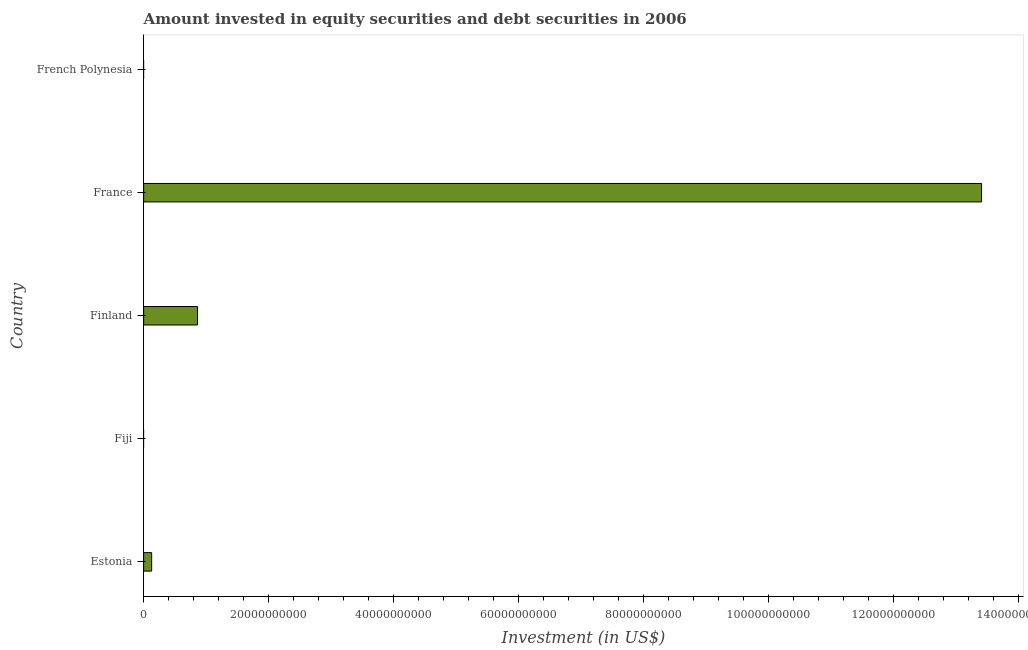Does the graph contain grids?
Your response must be concise. No. What is the title of the graph?
Your response must be concise. Amount invested in equity securities and debt securities in 2006. What is the label or title of the X-axis?
Keep it short and to the point. Investment (in US$). What is the label or title of the Y-axis?
Make the answer very short. Country. What is the portfolio investment in Finland?
Provide a succinct answer. 8.63e+09. Across all countries, what is the maximum portfolio investment?
Your answer should be compact. 1.34e+11. In which country was the portfolio investment maximum?
Your answer should be very brief. France. What is the sum of the portfolio investment?
Provide a short and direct response. 1.44e+11. What is the difference between the portfolio investment in Estonia and Finland?
Your answer should be very brief. -7.35e+09. What is the average portfolio investment per country?
Offer a terse response. 2.88e+1. What is the median portfolio investment?
Provide a succinct answer. 1.28e+09. Is the difference between the portfolio investment in Finland and France greater than the difference between any two countries?
Your response must be concise. No. What is the difference between the highest and the second highest portfolio investment?
Keep it short and to the point. 1.26e+11. Is the sum of the portfolio investment in Estonia and France greater than the maximum portfolio investment across all countries?
Provide a short and direct response. Yes. What is the difference between the highest and the lowest portfolio investment?
Provide a succinct answer. 1.34e+11. How many bars are there?
Keep it short and to the point. 3. How many countries are there in the graph?
Provide a short and direct response. 5. Are the values on the major ticks of X-axis written in scientific E-notation?
Your answer should be compact. No. What is the Investment (in US$) in Estonia?
Your response must be concise. 1.28e+09. What is the Investment (in US$) of Finland?
Offer a terse response. 8.63e+09. What is the Investment (in US$) in France?
Your response must be concise. 1.34e+11. What is the Investment (in US$) of French Polynesia?
Offer a very short reply. 0. What is the difference between the Investment (in US$) in Estonia and Finland?
Offer a terse response. -7.35e+09. What is the difference between the Investment (in US$) in Estonia and France?
Make the answer very short. -1.33e+11. What is the difference between the Investment (in US$) in Finland and France?
Give a very brief answer. -1.26e+11. What is the ratio of the Investment (in US$) in Estonia to that in Finland?
Give a very brief answer. 0.15. What is the ratio of the Investment (in US$) in Estonia to that in France?
Your response must be concise. 0.01. What is the ratio of the Investment (in US$) in Finland to that in France?
Offer a very short reply. 0.06. 